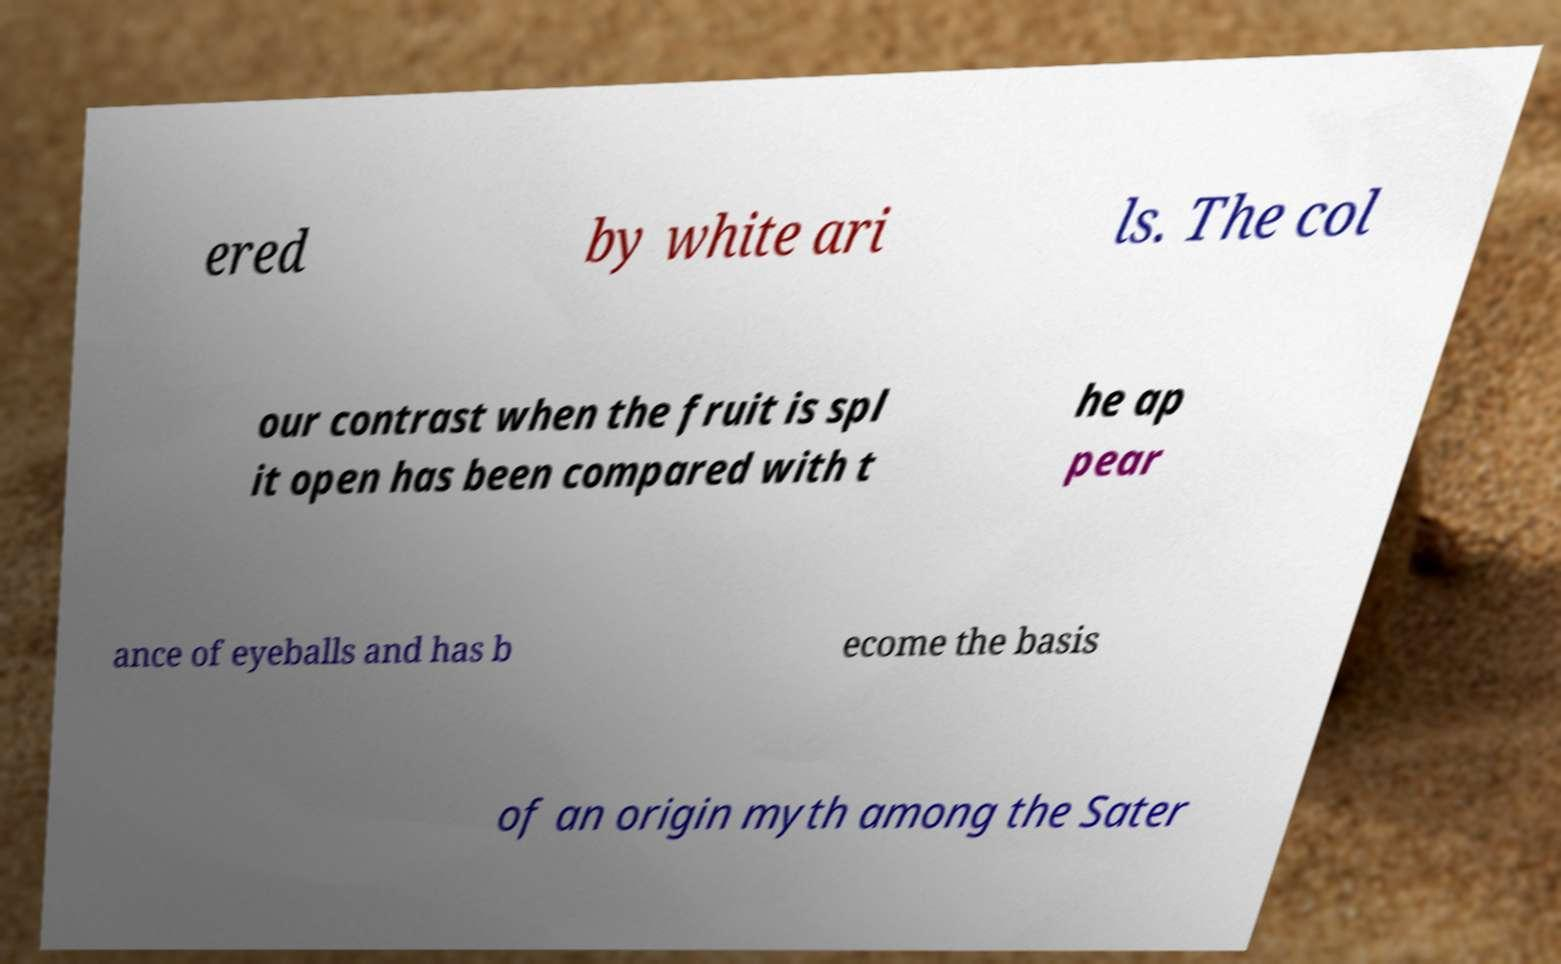Please identify and transcribe the text found in this image. ered by white ari ls. The col our contrast when the fruit is spl it open has been compared with t he ap pear ance of eyeballs and has b ecome the basis of an origin myth among the Sater 